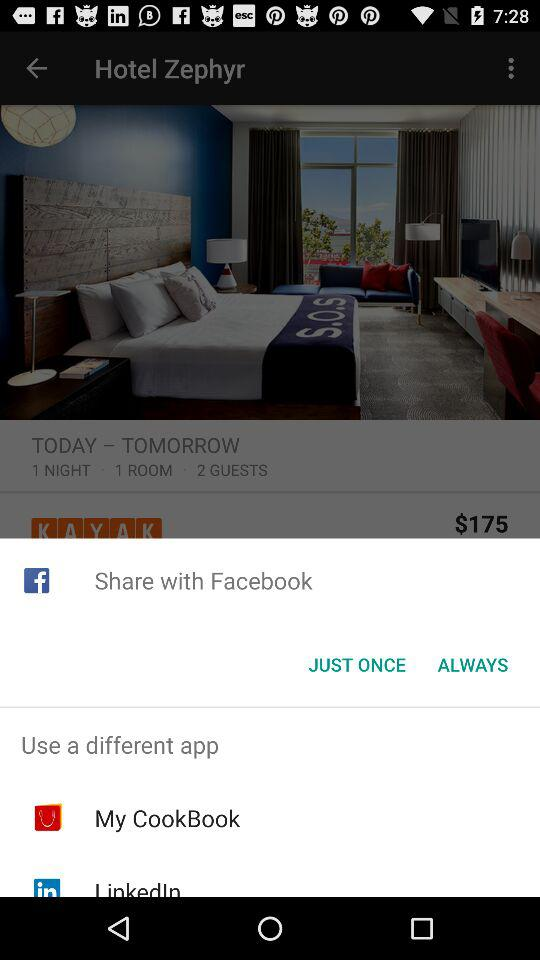Which applications can we use apart from "Facebook"? You can use "My CookBook" and "LinkedIn" applications apart from "Facebook". 